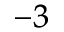<formula> <loc_0><loc_0><loc_500><loc_500>^ { - 3 }</formula> 